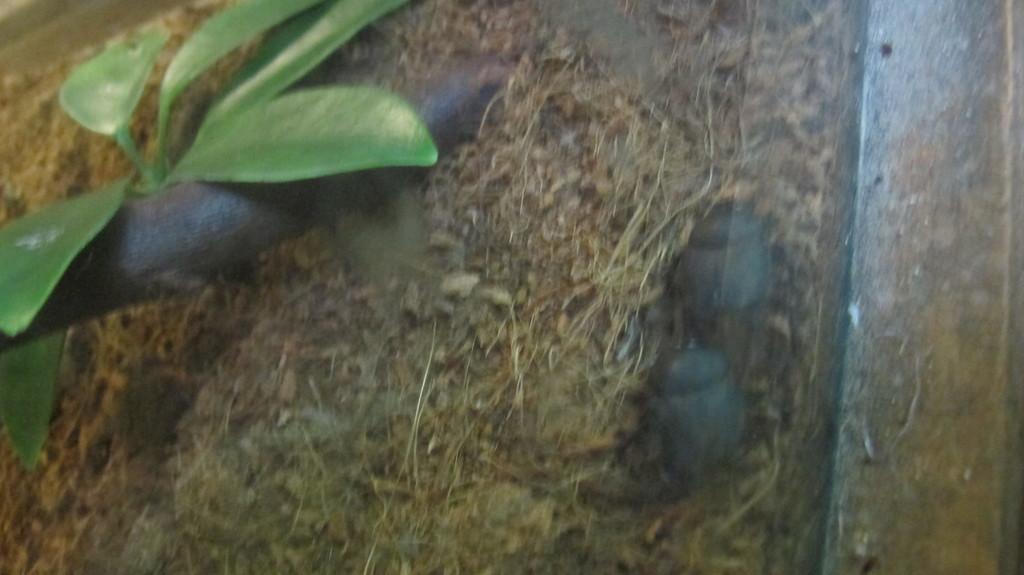Please provide a concise description of this image. In this image, we can see a small plant. 